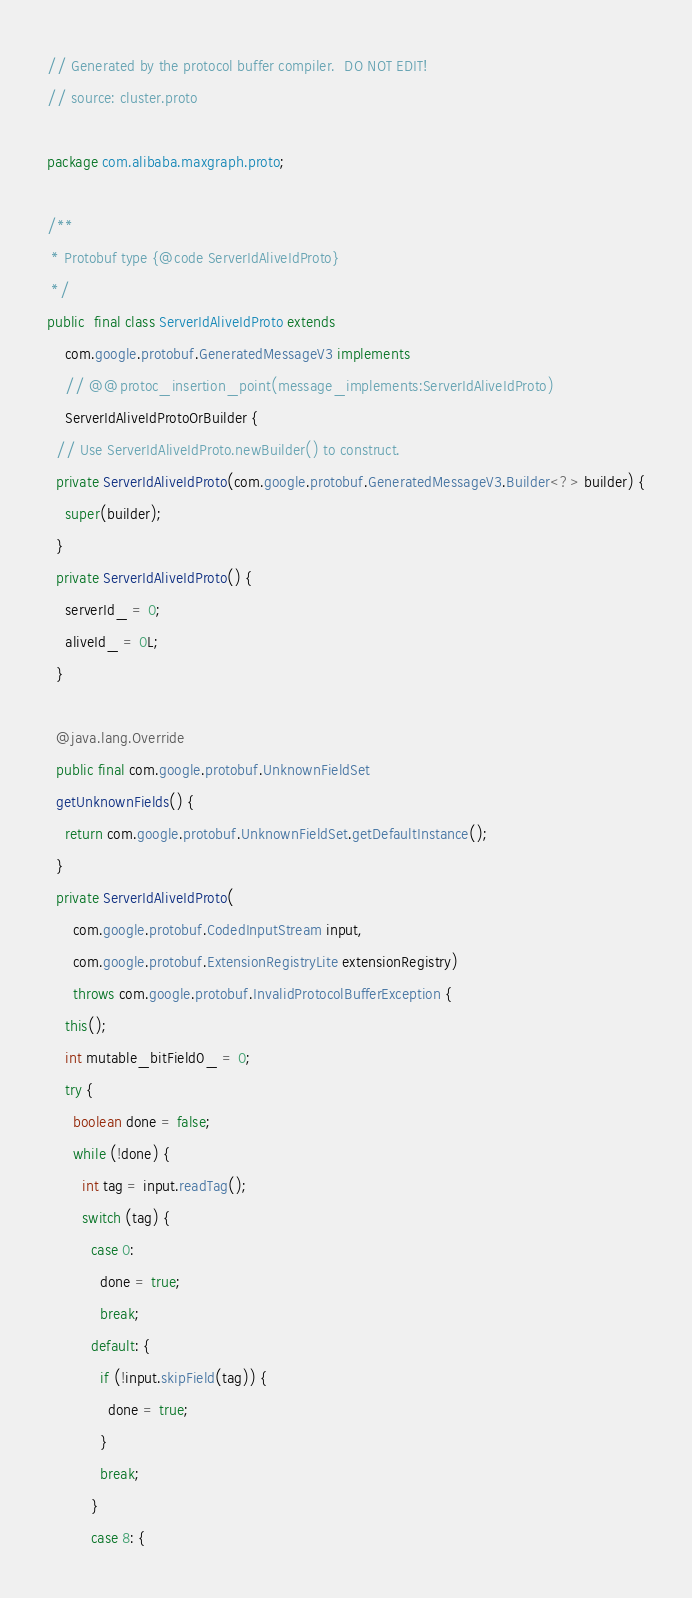Convert code to text. <code><loc_0><loc_0><loc_500><loc_500><_Java_>// Generated by the protocol buffer compiler.  DO NOT EDIT!
// source: cluster.proto

package com.alibaba.maxgraph.proto;

/**
 * Protobuf type {@code ServerIdAliveIdProto}
 */
public  final class ServerIdAliveIdProto extends
    com.google.protobuf.GeneratedMessageV3 implements
    // @@protoc_insertion_point(message_implements:ServerIdAliveIdProto)
    ServerIdAliveIdProtoOrBuilder {
  // Use ServerIdAliveIdProto.newBuilder() to construct.
  private ServerIdAliveIdProto(com.google.protobuf.GeneratedMessageV3.Builder<?> builder) {
    super(builder);
  }
  private ServerIdAliveIdProto() {
    serverId_ = 0;
    aliveId_ = 0L;
  }

  @java.lang.Override
  public final com.google.protobuf.UnknownFieldSet
  getUnknownFields() {
    return com.google.protobuf.UnknownFieldSet.getDefaultInstance();
  }
  private ServerIdAliveIdProto(
      com.google.protobuf.CodedInputStream input,
      com.google.protobuf.ExtensionRegistryLite extensionRegistry)
      throws com.google.protobuf.InvalidProtocolBufferException {
    this();
    int mutable_bitField0_ = 0;
    try {
      boolean done = false;
      while (!done) {
        int tag = input.readTag();
        switch (tag) {
          case 0:
            done = true;
            break;
          default: {
            if (!input.skipField(tag)) {
              done = true;
            }
            break;
          }
          case 8: {
</code> 